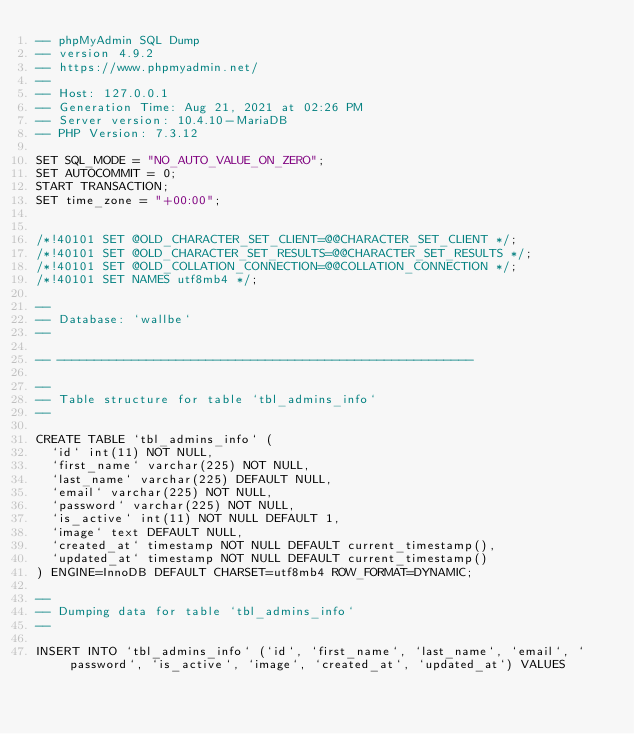Convert code to text. <code><loc_0><loc_0><loc_500><loc_500><_SQL_>-- phpMyAdmin SQL Dump
-- version 4.9.2
-- https://www.phpmyadmin.net/
--
-- Host: 127.0.0.1
-- Generation Time: Aug 21, 2021 at 02:26 PM
-- Server version: 10.4.10-MariaDB
-- PHP Version: 7.3.12

SET SQL_MODE = "NO_AUTO_VALUE_ON_ZERO";
SET AUTOCOMMIT = 0;
START TRANSACTION;
SET time_zone = "+00:00";


/*!40101 SET @OLD_CHARACTER_SET_CLIENT=@@CHARACTER_SET_CLIENT */;
/*!40101 SET @OLD_CHARACTER_SET_RESULTS=@@CHARACTER_SET_RESULTS */;
/*!40101 SET @OLD_COLLATION_CONNECTION=@@COLLATION_CONNECTION */;
/*!40101 SET NAMES utf8mb4 */;

--
-- Database: `wallbe`
--

-- --------------------------------------------------------

--
-- Table structure for table `tbl_admins_info`
--

CREATE TABLE `tbl_admins_info` (
  `id` int(11) NOT NULL,
  `first_name` varchar(225) NOT NULL,
  `last_name` varchar(225) DEFAULT NULL,
  `email` varchar(225) NOT NULL,
  `password` varchar(225) NOT NULL,
  `is_active` int(11) NOT NULL DEFAULT 1,
  `image` text DEFAULT NULL,
  `created_at` timestamp NOT NULL DEFAULT current_timestamp(),
  `updated_at` timestamp NOT NULL DEFAULT current_timestamp()
) ENGINE=InnoDB DEFAULT CHARSET=utf8mb4 ROW_FORMAT=DYNAMIC;

--
-- Dumping data for table `tbl_admins_info`
--

INSERT INTO `tbl_admins_info` (`id`, `first_name`, `last_name`, `email`, `password`, `is_active`, `image`, `created_at`, `updated_at`) VALUES</code> 